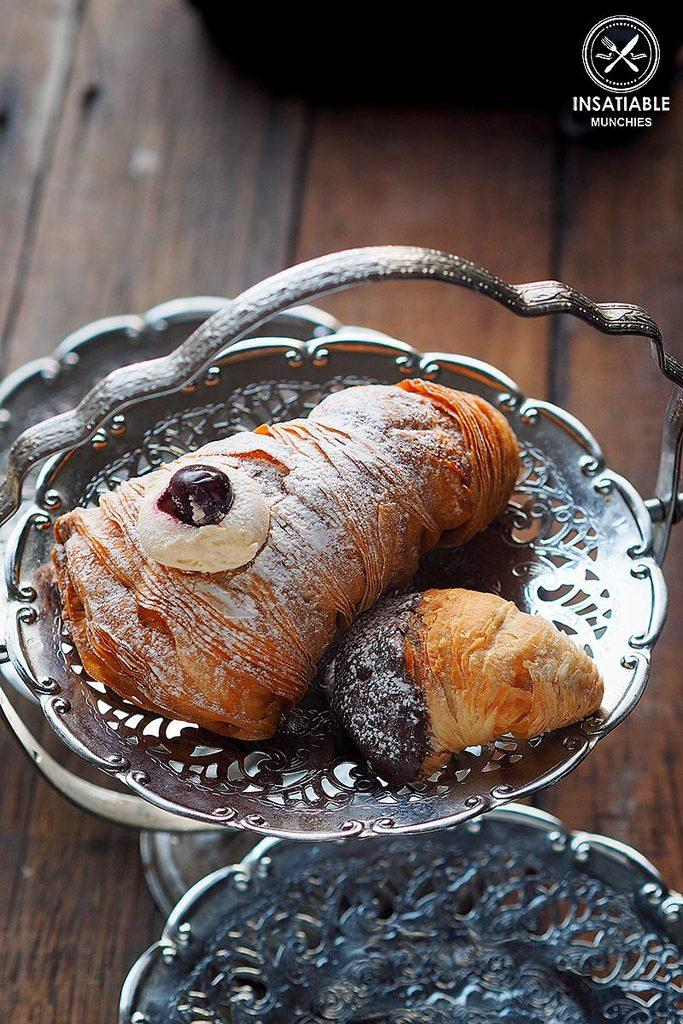What is inside the container that is visible in the image? There is food in a container in the image. Where are the containers located in the image? The containers are placed on a table in the image. What type of metal is used to create the picture on the table in the image? There is no picture on the table in the image, and therefore no metal is used to create it. 